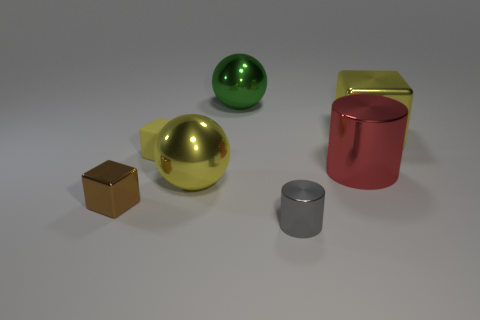What is the shape of the yellow thing right of the green ball?
Keep it short and to the point. Cube. The metallic cube that is to the left of the shiny block that is on the right side of the small brown thing is what color?
Offer a very short reply. Brown. What color is the large thing that is the same shape as the small gray thing?
Your answer should be compact. Red. What number of cubes are the same color as the tiny matte object?
Offer a very short reply. 1. Do the rubber object and the small object in front of the brown metallic thing have the same color?
Offer a very short reply. No. What is the shape of the small thing that is in front of the tiny yellow block and on the right side of the small brown thing?
Keep it short and to the point. Cylinder. What material is the cylinder that is in front of the tiny shiny object that is on the left side of the big sphere behind the matte cube?
Offer a terse response. Metal. Are there more big spheres behind the big yellow block than large red things to the right of the big red shiny cylinder?
Your answer should be compact. Yes. How many red objects have the same material as the large cube?
Provide a short and direct response. 1. There is a small thing that is to the right of the rubber cube; is it the same shape as the yellow metal thing that is on the left side of the red thing?
Offer a very short reply. No. 